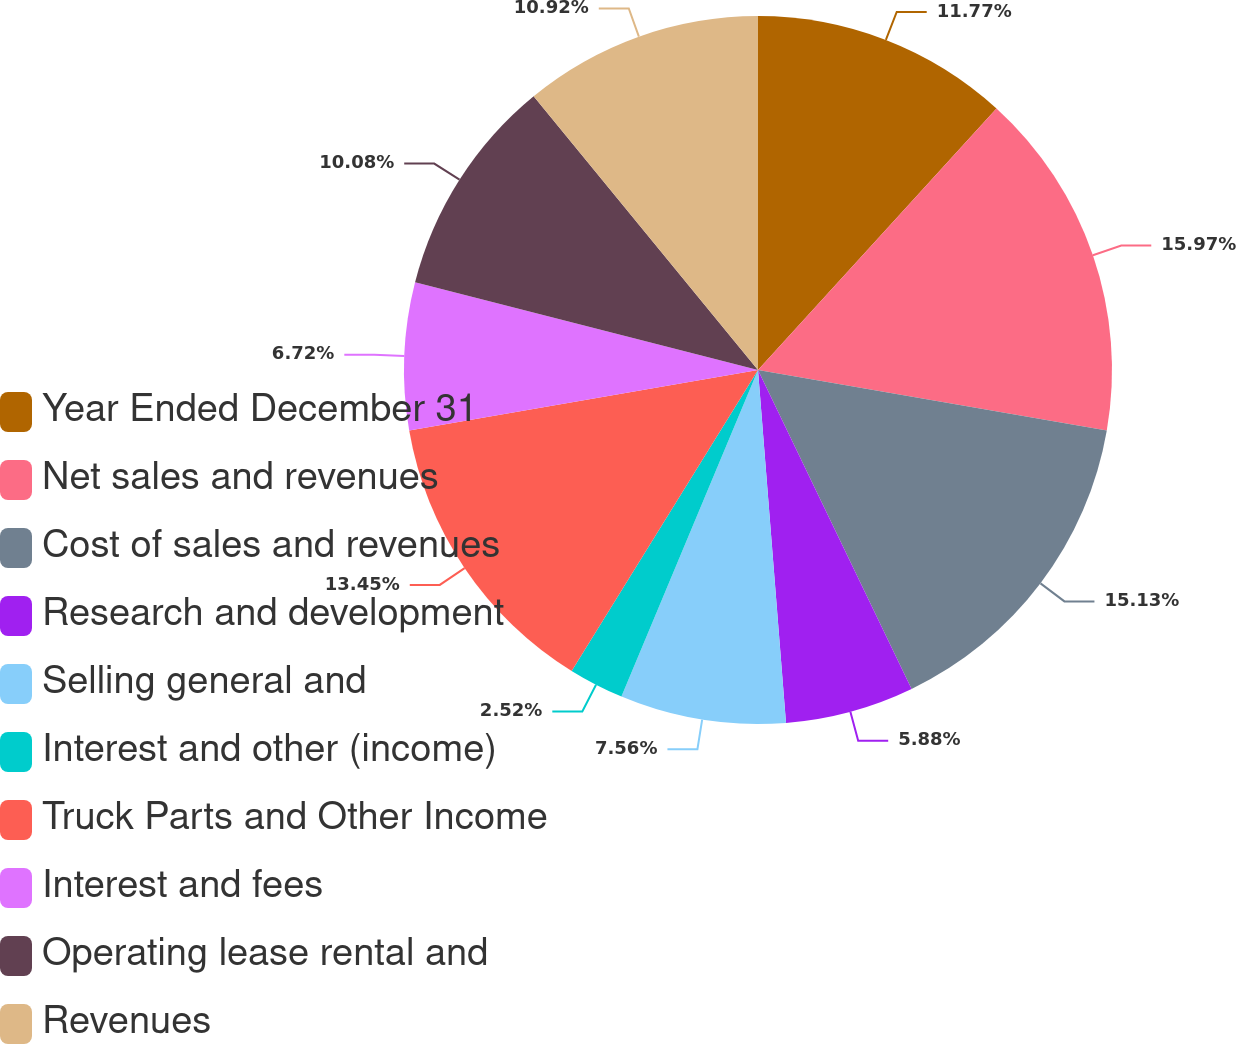<chart> <loc_0><loc_0><loc_500><loc_500><pie_chart><fcel>Year Ended December 31<fcel>Net sales and revenues<fcel>Cost of sales and revenues<fcel>Research and development<fcel>Selling general and<fcel>Interest and other (income)<fcel>Truck Parts and Other Income<fcel>Interest and fees<fcel>Operating lease rental and<fcel>Revenues<nl><fcel>11.76%<fcel>15.96%<fcel>15.12%<fcel>5.88%<fcel>7.56%<fcel>2.52%<fcel>13.44%<fcel>6.72%<fcel>10.08%<fcel>10.92%<nl></chart> 